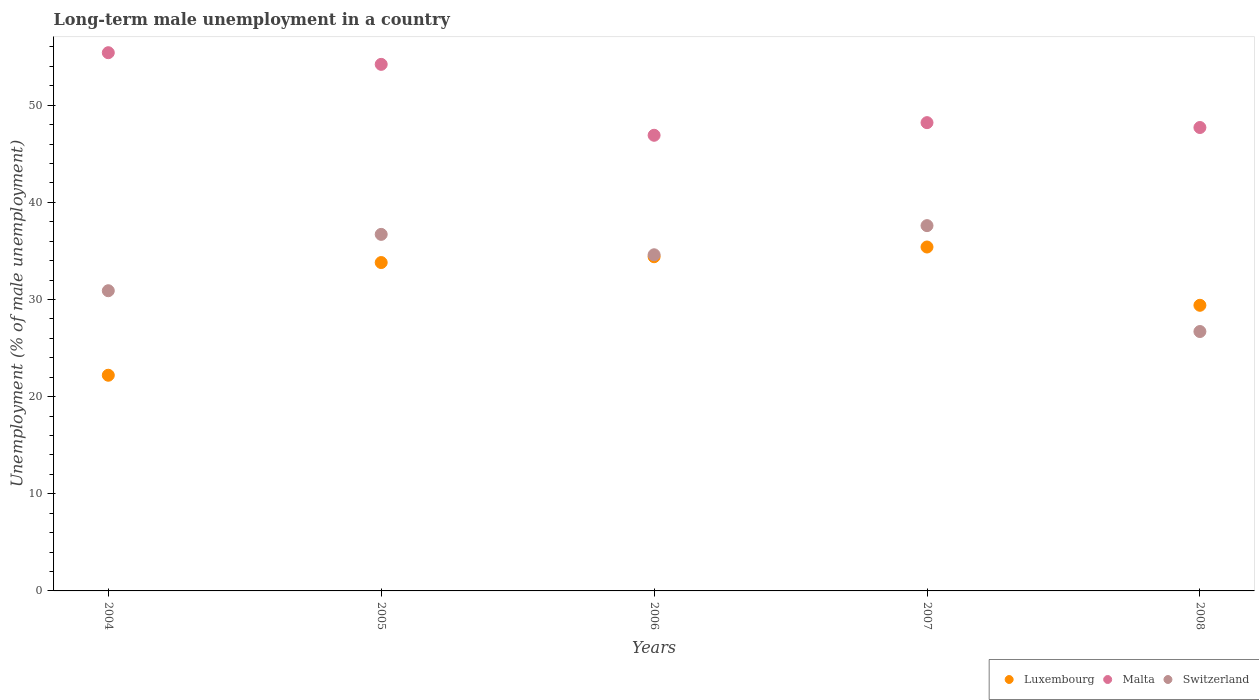What is the percentage of long-term unemployed male population in Malta in 2006?
Give a very brief answer. 46.9. Across all years, what is the maximum percentage of long-term unemployed male population in Switzerland?
Offer a terse response. 37.6. Across all years, what is the minimum percentage of long-term unemployed male population in Malta?
Ensure brevity in your answer.  46.9. In which year was the percentage of long-term unemployed male population in Malta maximum?
Your answer should be very brief. 2004. In which year was the percentage of long-term unemployed male population in Switzerland minimum?
Offer a very short reply. 2008. What is the total percentage of long-term unemployed male population in Luxembourg in the graph?
Offer a very short reply. 155.2. What is the difference between the percentage of long-term unemployed male population in Malta in 2005 and that in 2007?
Make the answer very short. 6. What is the difference between the percentage of long-term unemployed male population in Switzerland in 2004 and the percentage of long-term unemployed male population in Malta in 2008?
Your answer should be very brief. -16.8. What is the average percentage of long-term unemployed male population in Switzerland per year?
Make the answer very short. 33.3. In the year 2005, what is the difference between the percentage of long-term unemployed male population in Luxembourg and percentage of long-term unemployed male population in Switzerland?
Offer a very short reply. -2.9. In how many years, is the percentage of long-term unemployed male population in Malta greater than 30 %?
Offer a terse response. 5. What is the ratio of the percentage of long-term unemployed male population in Luxembourg in 2004 to that in 2008?
Ensure brevity in your answer.  0.76. Is the percentage of long-term unemployed male population in Luxembourg in 2006 less than that in 2007?
Your answer should be compact. Yes. What is the difference between the highest and the second highest percentage of long-term unemployed male population in Luxembourg?
Keep it short and to the point. 1. What is the difference between the highest and the lowest percentage of long-term unemployed male population in Luxembourg?
Make the answer very short. 13.2. In how many years, is the percentage of long-term unemployed male population in Luxembourg greater than the average percentage of long-term unemployed male population in Luxembourg taken over all years?
Your response must be concise. 3. Is it the case that in every year, the sum of the percentage of long-term unemployed male population in Malta and percentage of long-term unemployed male population in Switzerland  is greater than the percentage of long-term unemployed male population in Luxembourg?
Make the answer very short. Yes. Is the percentage of long-term unemployed male population in Malta strictly greater than the percentage of long-term unemployed male population in Luxembourg over the years?
Offer a very short reply. Yes. Are the values on the major ticks of Y-axis written in scientific E-notation?
Keep it short and to the point. No. Does the graph contain any zero values?
Offer a very short reply. No. Does the graph contain grids?
Offer a terse response. No. Where does the legend appear in the graph?
Your answer should be very brief. Bottom right. How many legend labels are there?
Offer a very short reply. 3. What is the title of the graph?
Provide a short and direct response. Long-term male unemployment in a country. Does "Syrian Arab Republic" appear as one of the legend labels in the graph?
Offer a terse response. No. What is the label or title of the Y-axis?
Offer a very short reply. Unemployment (% of male unemployment). What is the Unemployment (% of male unemployment) of Luxembourg in 2004?
Give a very brief answer. 22.2. What is the Unemployment (% of male unemployment) of Malta in 2004?
Provide a short and direct response. 55.4. What is the Unemployment (% of male unemployment) in Switzerland in 2004?
Provide a succinct answer. 30.9. What is the Unemployment (% of male unemployment) of Luxembourg in 2005?
Ensure brevity in your answer.  33.8. What is the Unemployment (% of male unemployment) of Malta in 2005?
Provide a short and direct response. 54.2. What is the Unemployment (% of male unemployment) in Switzerland in 2005?
Offer a very short reply. 36.7. What is the Unemployment (% of male unemployment) of Luxembourg in 2006?
Make the answer very short. 34.4. What is the Unemployment (% of male unemployment) of Malta in 2006?
Provide a succinct answer. 46.9. What is the Unemployment (% of male unemployment) in Switzerland in 2006?
Make the answer very short. 34.6. What is the Unemployment (% of male unemployment) of Luxembourg in 2007?
Provide a short and direct response. 35.4. What is the Unemployment (% of male unemployment) of Malta in 2007?
Make the answer very short. 48.2. What is the Unemployment (% of male unemployment) in Switzerland in 2007?
Keep it short and to the point. 37.6. What is the Unemployment (% of male unemployment) of Luxembourg in 2008?
Offer a very short reply. 29.4. What is the Unemployment (% of male unemployment) of Malta in 2008?
Provide a succinct answer. 47.7. What is the Unemployment (% of male unemployment) in Switzerland in 2008?
Keep it short and to the point. 26.7. Across all years, what is the maximum Unemployment (% of male unemployment) in Luxembourg?
Offer a terse response. 35.4. Across all years, what is the maximum Unemployment (% of male unemployment) in Malta?
Give a very brief answer. 55.4. Across all years, what is the maximum Unemployment (% of male unemployment) in Switzerland?
Your answer should be compact. 37.6. Across all years, what is the minimum Unemployment (% of male unemployment) in Luxembourg?
Offer a terse response. 22.2. Across all years, what is the minimum Unemployment (% of male unemployment) in Malta?
Your response must be concise. 46.9. Across all years, what is the minimum Unemployment (% of male unemployment) of Switzerland?
Make the answer very short. 26.7. What is the total Unemployment (% of male unemployment) in Luxembourg in the graph?
Give a very brief answer. 155.2. What is the total Unemployment (% of male unemployment) of Malta in the graph?
Provide a short and direct response. 252.4. What is the total Unemployment (% of male unemployment) of Switzerland in the graph?
Your response must be concise. 166.5. What is the difference between the Unemployment (% of male unemployment) in Malta in 2004 and that in 2005?
Your answer should be compact. 1.2. What is the difference between the Unemployment (% of male unemployment) in Luxembourg in 2004 and that in 2006?
Make the answer very short. -12.2. What is the difference between the Unemployment (% of male unemployment) in Switzerland in 2004 and that in 2006?
Provide a succinct answer. -3.7. What is the difference between the Unemployment (% of male unemployment) of Luxembourg in 2004 and that in 2007?
Your answer should be very brief. -13.2. What is the difference between the Unemployment (% of male unemployment) in Switzerland in 2004 and that in 2007?
Make the answer very short. -6.7. What is the difference between the Unemployment (% of male unemployment) of Luxembourg in 2005 and that in 2006?
Your response must be concise. -0.6. What is the difference between the Unemployment (% of male unemployment) in Malta in 2005 and that in 2006?
Make the answer very short. 7.3. What is the difference between the Unemployment (% of male unemployment) of Luxembourg in 2005 and that in 2007?
Keep it short and to the point. -1.6. What is the difference between the Unemployment (% of male unemployment) in Malta in 2005 and that in 2007?
Provide a short and direct response. 6. What is the difference between the Unemployment (% of male unemployment) in Switzerland in 2005 and that in 2007?
Your response must be concise. -0.9. What is the difference between the Unemployment (% of male unemployment) of Malta in 2005 and that in 2008?
Your answer should be compact. 6.5. What is the difference between the Unemployment (% of male unemployment) in Switzerland in 2005 and that in 2008?
Keep it short and to the point. 10. What is the difference between the Unemployment (% of male unemployment) in Malta in 2006 and that in 2007?
Keep it short and to the point. -1.3. What is the difference between the Unemployment (% of male unemployment) in Switzerland in 2006 and that in 2007?
Keep it short and to the point. -3. What is the difference between the Unemployment (% of male unemployment) in Malta in 2006 and that in 2008?
Your response must be concise. -0.8. What is the difference between the Unemployment (% of male unemployment) of Luxembourg in 2004 and the Unemployment (% of male unemployment) of Malta in 2005?
Provide a short and direct response. -32. What is the difference between the Unemployment (% of male unemployment) of Luxembourg in 2004 and the Unemployment (% of male unemployment) of Switzerland in 2005?
Your answer should be compact. -14.5. What is the difference between the Unemployment (% of male unemployment) of Luxembourg in 2004 and the Unemployment (% of male unemployment) of Malta in 2006?
Provide a short and direct response. -24.7. What is the difference between the Unemployment (% of male unemployment) in Malta in 2004 and the Unemployment (% of male unemployment) in Switzerland in 2006?
Keep it short and to the point. 20.8. What is the difference between the Unemployment (% of male unemployment) in Luxembourg in 2004 and the Unemployment (% of male unemployment) in Switzerland in 2007?
Provide a succinct answer. -15.4. What is the difference between the Unemployment (% of male unemployment) of Luxembourg in 2004 and the Unemployment (% of male unemployment) of Malta in 2008?
Offer a very short reply. -25.5. What is the difference between the Unemployment (% of male unemployment) of Malta in 2004 and the Unemployment (% of male unemployment) of Switzerland in 2008?
Give a very brief answer. 28.7. What is the difference between the Unemployment (% of male unemployment) in Luxembourg in 2005 and the Unemployment (% of male unemployment) in Switzerland in 2006?
Give a very brief answer. -0.8. What is the difference between the Unemployment (% of male unemployment) of Malta in 2005 and the Unemployment (% of male unemployment) of Switzerland in 2006?
Ensure brevity in your answer.  19.6. What is the difference between the Unemployment (% of male unemployment) of Luxembourg in 2005 and the Unemployment (% of male unemployment) of Malta in 2007?
Ensure brevity in your answer.  -14.4. What is the difference between the Unemployment (% of male unemployment) of Luxembourg in 2005 and the Unemployment (% of male unemployment) of Switzerland in 2007?
Your response must be concise. -3.8. What is the difference between the Unemployment (% of male unemployment) of Luxembourg in 2005 and the Unemployment (% of male unemployment) of Malta in 2008?
Your response must be concise. -13.9. What is the difference between the Unemployment (% of male unemployment) of Luxembourg in 2005 and the Unemployment (% of male unemployment) of Switzerland in 2008?
Your response must be concise. 7.1. What is the difference between the Unemployment (% of male unemployment) in Luxembourg in 2006 and the Unemployment (% of male unemployment) in Switzerland in 2007?
Give a very brief answer. -3.2. What is the difference between the Unemployment (% of male unemployment) of Luxembourg in 2006 and the Unemployment (% of male unemployment) of Malta in 2008?
Provide a succinct answer. -13.3. What is the difference between the Unemployment (% of male unemployment) in Malta in 2006 and the Unemployment (% of male unemployment) in Switzerland in 2008?
Your response must be concise. 20.2. What is the difference between the Unemployment (% of male unemployment) of Malta in 2007 and the Unemployment (% of male unemployment) of Switzerland in 2008?
Keep it short and to the point. 21.5. What is the average Unemployment (% of male unemployment) of Luxembourg per year?
Keep it short and to the point. 31.04. What is the average Unemployment (% of male unemployment) in Malta per year?
Provide a succinct answer. 50.48. What is the average Unemployment (% of male unemployment) of Switzerland per year?
Keep it short and to the point. 33.3. In the year 2004, what is the difference between the Unemployment (% of male unemployment) of Luxembourg and Unemployment (% of male unemployment) of Malta?
Offer a terse response. -33.2. In the year 2004, what is the difference between the Unemployment (% of male unemployment) in Malta and Unemployment (% of male unemployment) in Switzerland?
Provide a short and direct response. 24.5. In the year 2005, what is the difference between the Unemployment (% of male unemployment) in Luxembourg and Unemployment (% of male unemployment) in Malta?
Make the answer very short. -20.4. In the year 2005, what is the difference between the Unemployment (% of male unemployment) of Malta and Unemployment (% of male unemployment) of Switzerland?
Your answer should be very brief. 17.5. In the year 2006, what is the difference between the Unemployment (% of male unemployment) in Luxembourg and Unemployment (% of male unemployment) in Malta?
Your answer should be very brief. -12.5. In the year 2007, what is the difference between the Unemployment (% of male unemployment) of Luxembourg and Unemployment (% of male unemployment) of Malta?
Ensure brevity in your answer.  -12.8. In the year 2007, what is the difference between the Unemployment (% of male unemployment) in Malta and Unemployment (% of male unemployment) in Switzerland?
Your answer should be compact. 10.6. In the year 2008, what is the difference between the Unemployment (% of male unemployment) of Luxembourg and Unemployment (% of male unemployment) of Malta?
Give a very brief answer. -18.3. In the year 2008, what is the difference between the Unemployment (% of male unemployment) of Luxembourg and Unemployment (% of male unemployment) of Switzerland?
Offer a terse response. 2.7. In the year 2008, what is the difference between the Unemployment (% of male unemployment) of Malta and Unemployment (% of male unemployment) of Switzerland?
Your answer should be very brief. 21. What is the ratio of the Unemployment (% of male unemployment) of Luxembourg in 2004 to that in 2005?
Make the answer very short. 0.66. What is the ratio of the Unemployment (% of male unemployment) of Malta in 2004 to that in 2005?
Make the answer very short. 1.02. What is the ratio of the Unemployment (% of male unemployment) of Switzerland in 2004 to that in 2005?
Make the answer very short. 0.84. What is the ratio of the Unemployment (% of male unemployment) in Luxembourg in 2004 to that in 2006?
Offer a terse response. 0.65. What is the ratio of the Unemployment (% of male unemployment) in Malta in 2004 to that in 2006?
Provide a succinct answer. 1.18. What is the ratio of the Unemployment (% of male unemployment) of Switzerland in 2004 to that in 2006?
Your answer should be very brief. 0.89. What is the ratio of the Unemployment (% of male unemployment) of Luxembourg in 2004 to that in 2007?
Ensure brevity in your answer.  0.63. What is the ratio of the Unemployment (% of male unemployment) of Malta in 2004 to that in 2007?
Offer a terse response. 1.15. What is the ratio of the Unemployment (% of male unemployment) in Switzerland in 2004 to that in 2007?
Provide a short and direct response. 0.82. What is the ratio of the Unemployment (% of male unemployment) in Luxembourg in 2004 to that in 2008?
Provide a succinct answer. 0.76. What is the ratio of the Unemployment (% of male unemployment) of Malta in 2004 to that in 2008?
Provide a short and direct response. 1.16. What is the ratio of the Unemployment (% of male unemployment) of Switzerland in 2004 to that in 2008?
Make the answer very short. 1.16. What is the ratio of the Unemployment (% of male unemployment) of Luxembourg in 2005 to that in 2006?
Offer a terse response. 0.98. What is the ratio of the Unemployment (% of male unemployment) in Malta in 2005 to that in 2006?
Offer a very short reply. 1.16. What is the ratio of the Unemployment (% of male unemployment) in Switzerland in 2005 to that in 2006?
Your answer should be compact. 1.06. What is the ratio of the Unemployment (% of male unemployment) of Luxembourg in 2005 to that in 2007?
Ensure brevity in your answer.  0.95. What is the ratio of the Unemployment (% of male unemployment) in Malta in 2005 to that in 2007?
Your response must be concise. 1.12. What is the ratio of the Unemployment (% of male unemployment) in Switzerland in 2005 to that in 2007?
Your answer should be compact. 0.98. What is the ratio of the Unemployment (% of male unemployment) in Luxembourg in 2005 to that in 2008?
Offer a very short reply. 1.15. What is the ratio of the Unemployment (% of male unemployment) of Malta in 2005 to that in 2008?
Ensure brevity in your answer.  1.14. What is the ratio of the Unemployment (% of male unemployment) in Switzerland in 2005 to that in 2008?
Provide a succinct answer. 1.37. What is the ratio of the Unemployment (% of male unemployment) in Luxembourg in 2006 to that in 2007?
Ensure brevity in your answer.  0.97. What is the ratio of the Unemployment (% of male unemployment) in Switzerland in 2006 to that in 2007?
Provide a succinct answer. 0.92. What is the ratio of the Unemployment (% of male unemployment) in Luxembourg in 2006 to that in 2008?
Your answer should be compact. 1.17. What is the ratio of the Unemployment (% of male unemployment) of Malta in 2006 to that in 2008?
Your answer should be compact. 0.98. What is the ratio of the Unemployment (% of male unemployment) of Switzerland in 2006 to that in 2008?
Ensure brevity in your answer.  1.3. What is the ratio of the Unemployment (% of male unemployment) of Luxembourg in 2007 to that in 2008?
Ensure brevity in your answer.  1.2. What is the ratio of the Unemployment (% of male unemployment) of Malta in 2007 to that in 2008?
Offer a very short reply. 1.01. What is the ratio of the Unemployment (% of male unemployment) in Switzerland in 2007 to that in 2008?
Your answer should be compact. 1.41. What is the difference between the highest and the second highest Unemployment (% of male unemployment) in Switzerland?
Your response must be concise. 0.9. What is the difference between the highest and the lowest Unemployment (% of male unemployment) in Switzerland?
Your answer should be compact. 10.9. 